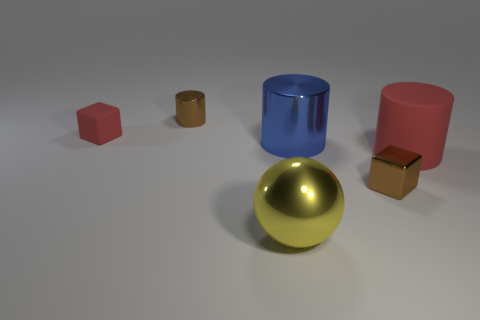Is the number of tiny brown shiny things to the right of the big matte cylinder greater than the number of large yellow shiny things behind the large yellow sphere?
Offer a terse response. No. There is a tiny cylinder; is its color the same as the cube in front of the small matte object?
Offer a very short reply. Yes. There is a blue thing that is the same size as the ball; what is it made of?
Offer a very short reply. Metal. How many objects are gray metal cubes or small metallic cylinders that are right of the small rubber object?
Provide a succinct answer. 1. Do the metallic cube and the shiny cylinder in front of the red rubber cube have the same size?
Keep it short and to the point. No. How many cylinders are tiny metallic things or blue metallic things?
Offer a terse response. 2. How many metallic objects are both left of the big blue metallic thing and behind the yellow metallic ball?
Make the answer very short. 1. How many other things are there of the same color as the metallic sphere?
Offer a terse response. 0. The big shiny object that is to the right of the large yellow metal ball has what shape?
Provide a succinct answer. Cylinder. Is the material of the ball the same as the large red object?
Provide a succinct answer. No. 